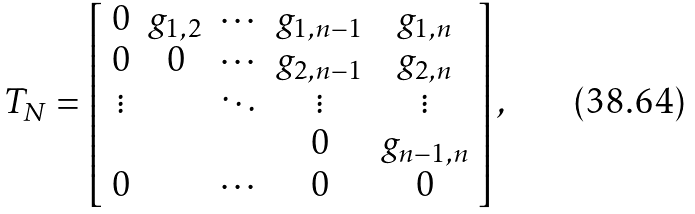Convert formula to latex. <formula><loc_0><loc_0><loc_500><loc_500>T _ { N } = \left [ \begin{array} { c c c c c } 0 & g _ { 1 , 2 } & \cdots & g _ { 1 , n - 1 } & g _ { 1 , n } \\ 0 & 0 & \cdots & g _ { 2 , n - 1 } & g _ { 2 , n } \\ \vdots & & \ddots & \vdots & \vdots \\ & & & 0 & g _ { n - 1 , n } \\ 0 & & \cdots & 0 & 0 \end{array} \right ] ,</formula> 